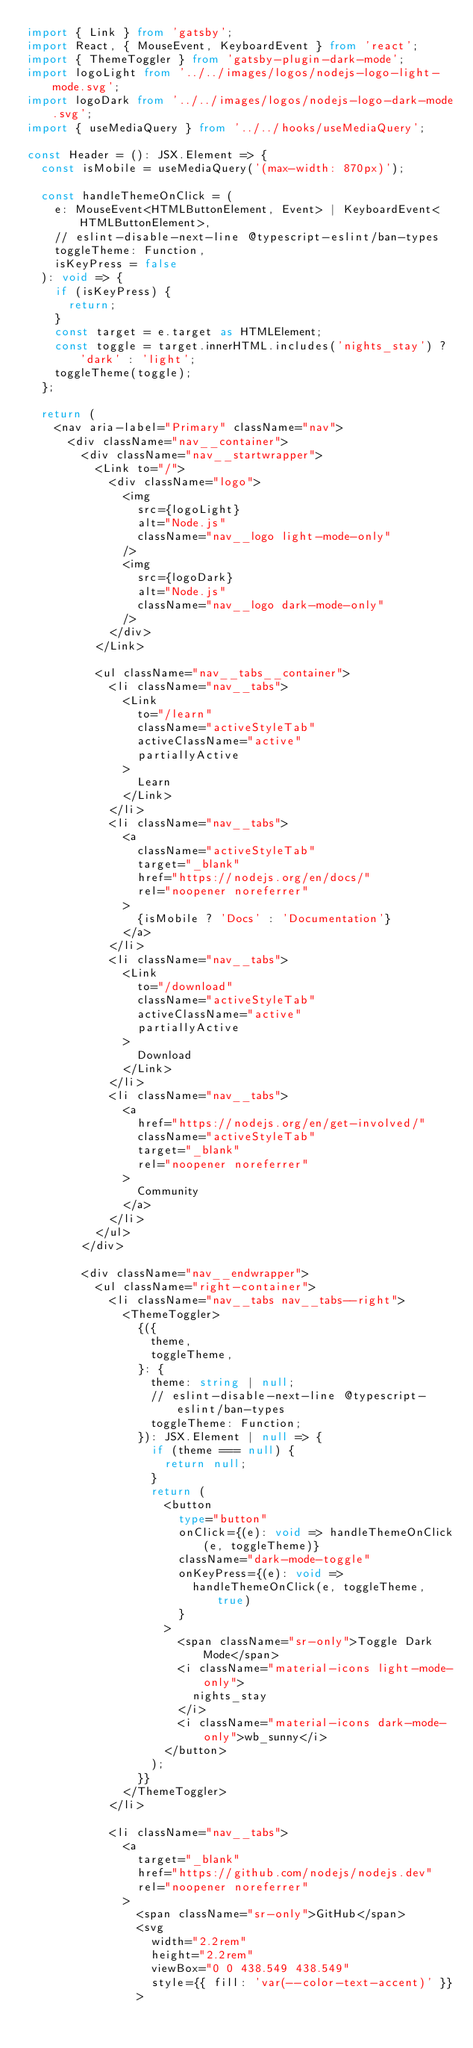<code> <loc_0><loc_0><loc_500><loc_500><_TypeScript_>import { Link } from 'gatsby';
import React, { MouseEvent, KeyboardEvent } from 'react';
import { ThemeToggler } from 'gatsby-plugin-dark-mode';
import logoLight from '../../images/logos/nodejs-logo-light-mode.svg';
import logoDark from '../../images/logos/nodejs-logo-dark-mode.svg';
import { useMediaQuery } from '../../hooks/useMediaQuery';

const Header = (): JSX.Element => {
  const isMobile = useMediaQuery('(max-width: 870px)');

  const handleThemeOnClick = (
    e: MouseEvent<HTMLButtonElement, Event> | KeyboardEvent<HTMLButtonElement>,
    // eslint-disable-next-line @typescript-eslint/ban-types
    toggleTheme: Function,
    isKeyPress = false
  ): void => {
    if (isKeyPress) {
      return;
    }
    const target = e.target as HTMLElement;
    const toggle = target.innerHTML.includes('nights_stay') ? 'dark' : 'light';
    toggleTheme(toggle);
  };

  return (
    <nav aria-label="Primary" className="nav">
      <div className="nav__container">
        <div className="nav__startwrapper">
          <Link to="/">
            <div className="logo">
              <img
                src={logoLight}
                alt="Node.js"
                className="nav__logo light-mode-only"
              />
              <img
                src={logoDark}
                alt="Node.js"
                className="nav__logo dark-mode-only"
              />
            </div>
          </Link>

          <ul className="nav__tabs__container">
            <li className="nav__tabs">
              <Link
                to="/learn"
                className="activeStyleTab"
                activeClassName="active"
                partiallyActive
              >
                Learn
              </Link>
            </li>
            <li className="nav__tabs">
              <a
                className="activeStyleTab"
                target="_blank"
                href="https://nodejs.org/en/docs/"
                rel="noopener noreferrer"
              >
                {isMobile ? 'Docs' : 'Documentation'}
              </a>
            </li>
            <li className="nav__tabs">
              <Link
                to="/download"
                className="activeStyleTab"
                activeClassName="active"
                partiallyActive
              >
                Download
              </Link>
            </li>
            <li className="nav__tabs">
              <a
                href="https://nodejs.org/en/get-involved/"
                className="activeStyleTab"
                target="_blank"
                rel="noopener noreferrer"
              >
                Community
              </a>
            </li>
          </ul>
        </div>

        <div className="nav__endwrapper">
          <ul className="right-container">
            <li className="nav__tabs nav__tabs--right">
              <ThemeToggler>
                {({
                  theme,
                  toggleTheme,
                }: {
                  theme: string | null;
                  // eslint-disable-next-line @typescript-eslint/ban-types
                  toggleTheme: Function;
                }): JSX.Element | null => {
                  if (theme === null) {
                    return null;
                  }
                  return (
                    <button
                      type="button"
                      onClick={(e): void => handleThemeOnClick(e, toggleTheme)}
                      className="dark-mode-toggle"
                      onKeyPress={(e): void =>
                        handleThemeOnClick(e, toggleTheme, true)
                      }
                    >
                      <span className="sr-only">Toggle Dark Mode</span>
                      <i className="material-icons light-mode-only">
                        nights_stay
                      </i>
                      <i className="material-icons dark-mode-only">wb_sunny</i>
                    </button>
                  );
                }}
              </ThemeToggler>
            </li>

            <li className="nav__tabs">
              <a
                target="_blank"
                href="https://github.com/nodejs/nodejs.dev"
                rel="noopener noreferrer"
              >
                <span className="sr-only">GitHub</span>
                <svg
                  width="2.2rem"
                  height="2.2rem"
                  viewBox="0 0 438.549 438.549"
                  style={{ fill: 'var(--color-text-accent)' }}
                ></code> 